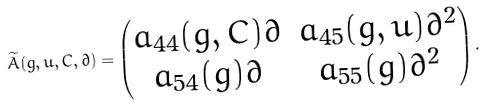<formula> <loc_0><loc_0><loc_500><loc_500>\widetilde { A } ( g , u , C , \partial ) = \left ( \begin{matrix} a _ { 4 4 } ( g , C ) \partial & a _ { 4 5 } ( g , u ) \partial ^ { 2 } \\ a _ { 5 4 } ( g ) \partial & a _ { 5 5 } ( g ) \partial ^ { 2 } \end{matrix} \right ) .</formula> 